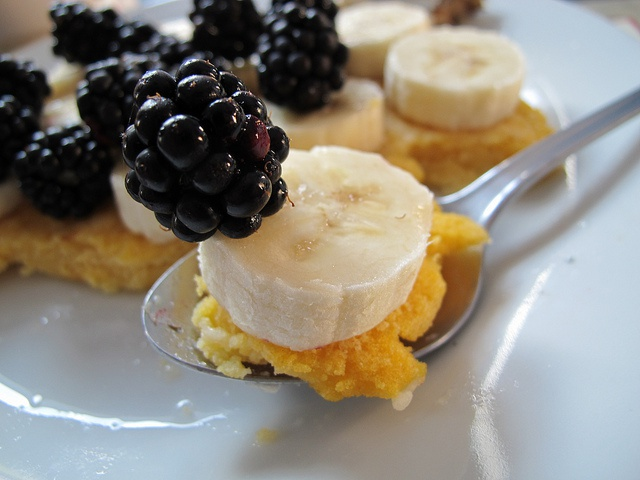Describe the objects in this image and their specific colors. I can see cake in gray, black, and tan tones, banana in gray, tan, and darkgray tones, spoon in gray and brown tones, banana in gray, tan, and lightgray tones, and banana in gray, tan, and darkgray tones in this image. 